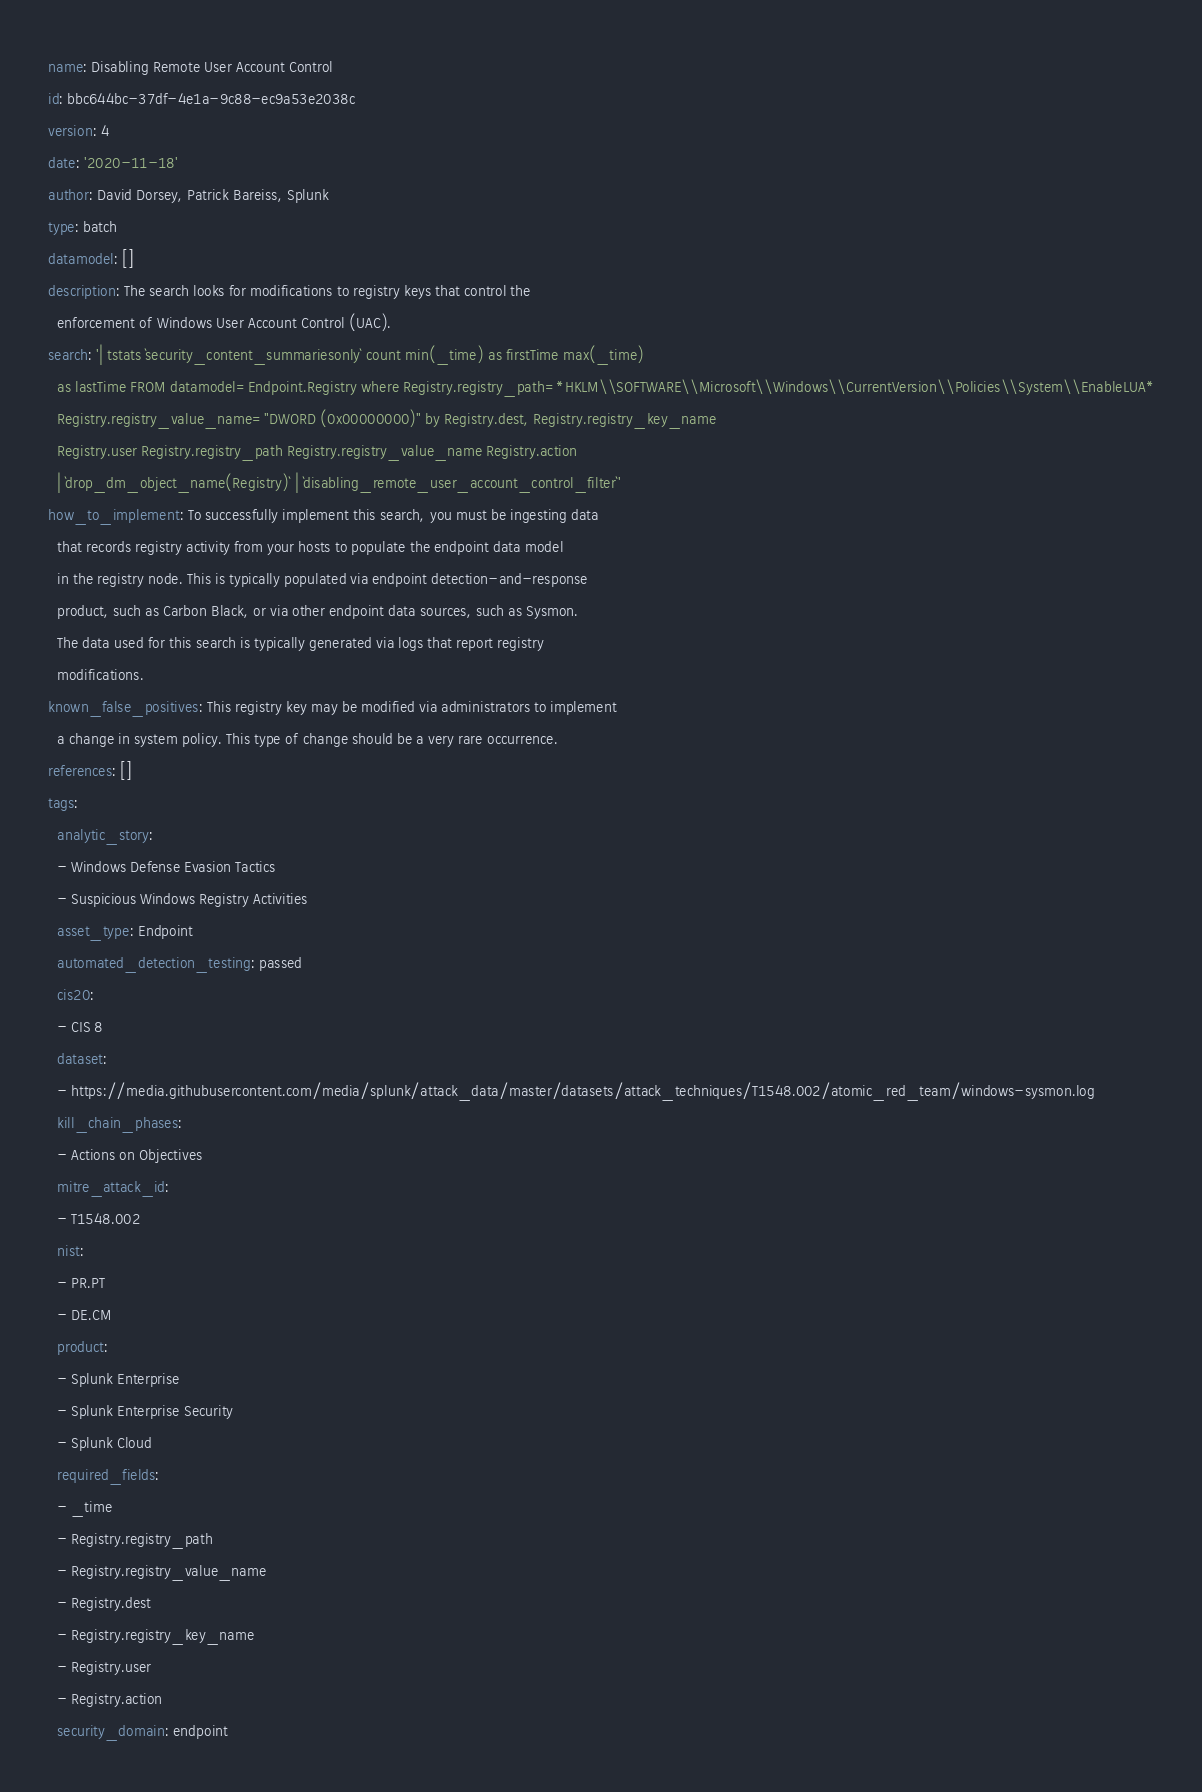<code> <loc_0><loc_0><loc_500><loc_500><_YAML_>name: Disabling Remote User Account Control
id: bbc644bc-37df-4e1a-9c88-ec9a53e2038c
version: 4
date: '2020-11-18'
author: David Dorsey, Patrick Bareiss, Splunk
type: batch
datamodel: []
description: The search looks for modifications to registry keys that control the
  enforcement of Windows User Account Control (UAC).
search: '| tstats `security_content_summariesonly` count min(_time) as firstTime max(_time)
  as lastTime FROM datamodel=Endpoint.Registry where Registry.registry_path=*HKLM\\SOFTWARE\\Microsoft\\Windows\\CurrentVersion\\Policies\\System\\EnableLUA*
  Registry.registry_value_name="DWORD (0x00000000)" by Registry.dest, Registry.registry_key_name
  Registry.user Registry.registry_path Registry.registry_value_name Registry.action
  | `drop_dm_object_name(Registry)` | `disabling_remote_user_account_control_filter`'
how_to_implement: To successfully implement this search, you must be ingesting data
  that records registry activity from your hosts to populate the endpoint data model
  in the registry node. This is typically populated via endpoint detection-and-response
  product, such as Carbon Black, or via other endpoint data sources, such as Sysmon.
  The data used for this search is typically generated via logs that report registry
  modifications.
known_false_positives: This registry key may be modified via administrators to implement
  a change in system policy. This type of change should be a very rare occurrence.
references: []
tags:
  analytic_story:
  - Windows Defense Evasion Tactics
  - Suspicious Windows Registry Activities
  asset_type: Endpoint
  automated_detection_testing: passed
  cis20:
  - CIS 8
  dataset:
  - https://media.githubusercontent.com/media/splunk/attack_data/master/datasets/attack_techniques/T1548.002/atomic_red_team/windows-sysmon.log
  kill_chain_phases:
  - Actions on Objectives
  mitre_attack_id:
  - T1548.002
  nist:
  - PR.PT
  - DE.CM
  product:
  - Splunk Enterprise
  - Splunk Enterprise Security
  - Splunk Cloud
  required_fields:
  - _time
  - Registry.registry_path
  - Registry.registry_value_name
  - Registry.dest
  - Registry.registry_key_name
  - Registry.user
  - Registry.action
  security_domain: endpoint
</code> 